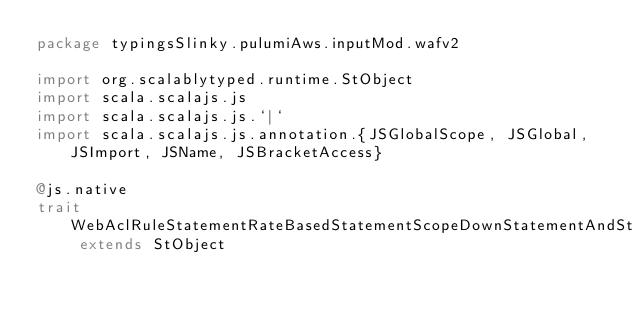<code> <loc_0><loc_0><loc_500><loc_500><_Scala_>package typingsSlinky.pulumiAws.inputMod.wafv2

import org.scalablytyped.runtime.StObject
import scala.scalajs.js
import scala.scalajs.js.`|`
import scala.scalajs.js.annotation.{JSGlobalScope, JSGlobal, JSImport, JSName, JSBracketAccess}

@js.native
trait WebAclRuleStatementRateBasedStatementScopeDownStatementAndStatementStatementNotStatementStatementSizeConstraintStatementFieldToMatchMethod extends StObject
</code> 